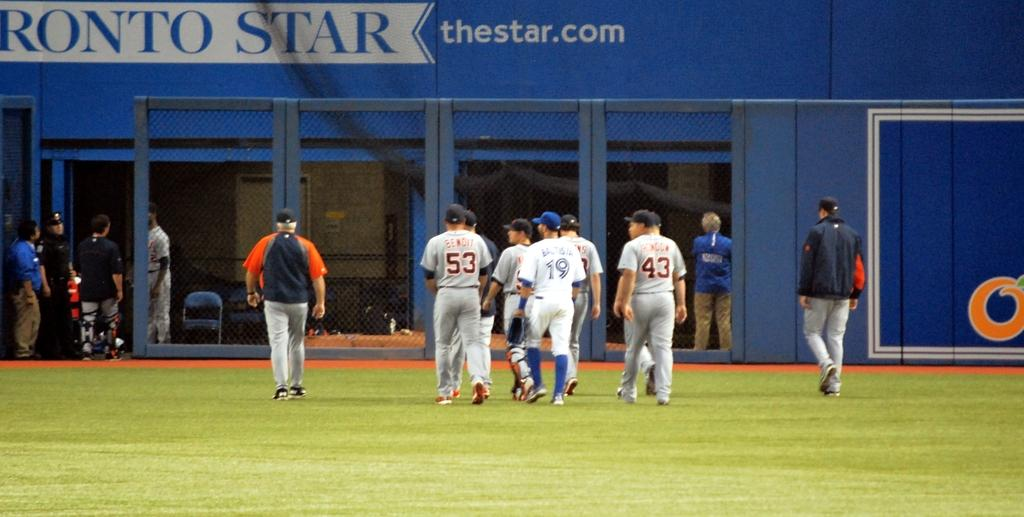<image>
Render a clear and concise summary of the photo. Ball players on a field sponsored by thestar.com. 